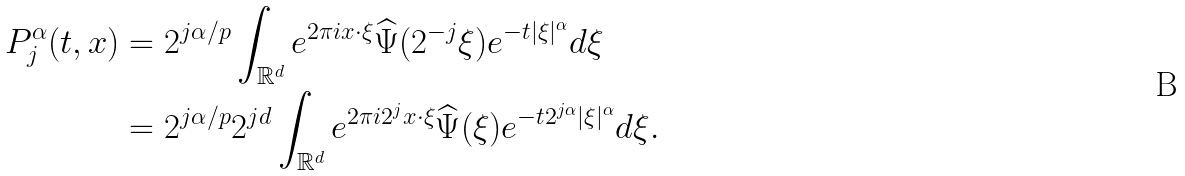Convert formula to latex. <formula><loc_0><loc_0><loc_500><loc_500>P _ { j } ^ { \alpha } ( t , x ) & = 2 ^ { j \alpha / p } \int _ { { \mathbb { R } } ^ { d } } e ^ { 2 \pi i x \cdot \xi } \widehat { \Psi } ( 2 ^ { - j } \xi ) e ^ { - t | \xi | ^ { \alpha } } d \xi \\ & = 2 ^ { j \alpha / p } 2 ^ { j d } \int _ { { \mathbb { R } } ^ { d } } e ^ { 2 \pi i 2 ^ { j } x \cdot \xi } \widehat { \Psi } ( \xi ) e ^ { - t 2 ^ { j \alpha } | \xi | ^ { \alpha } } d \xi .</formula> 